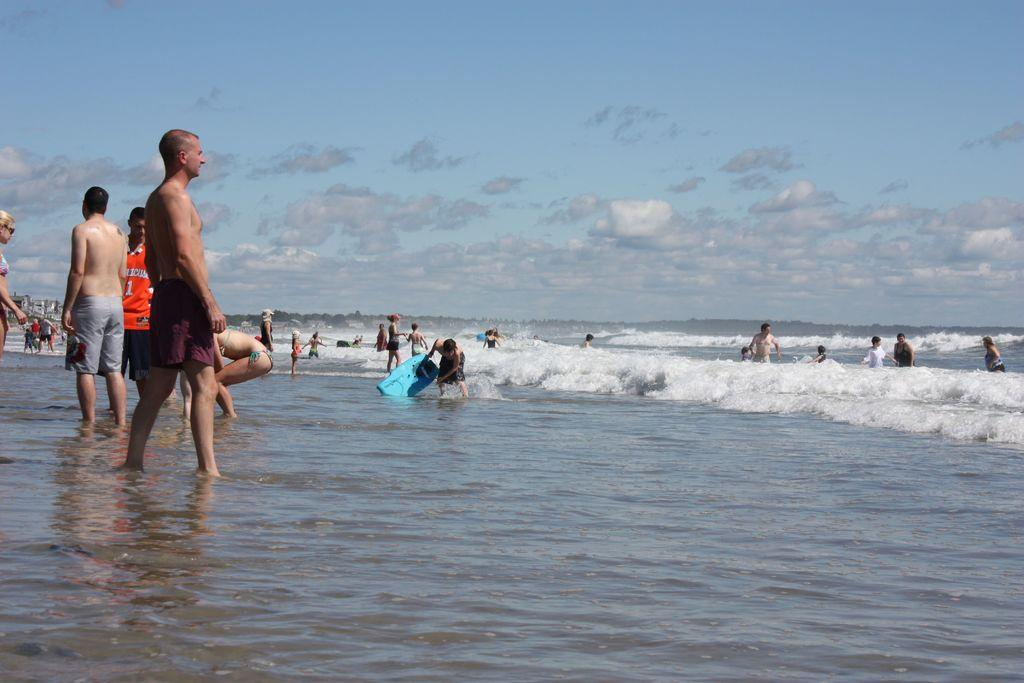Who is the main subject in the image? There is a man in the image. Where is the man located in the image? The man is on the left side of the image. What is the man wearing in the image? The man is wearing a shirt in the image. What can be seen in the background of the image? The background of the image is the sky. What type of rock is the man holding in the image? There is no rock present in the image; the man is not holding anything. 